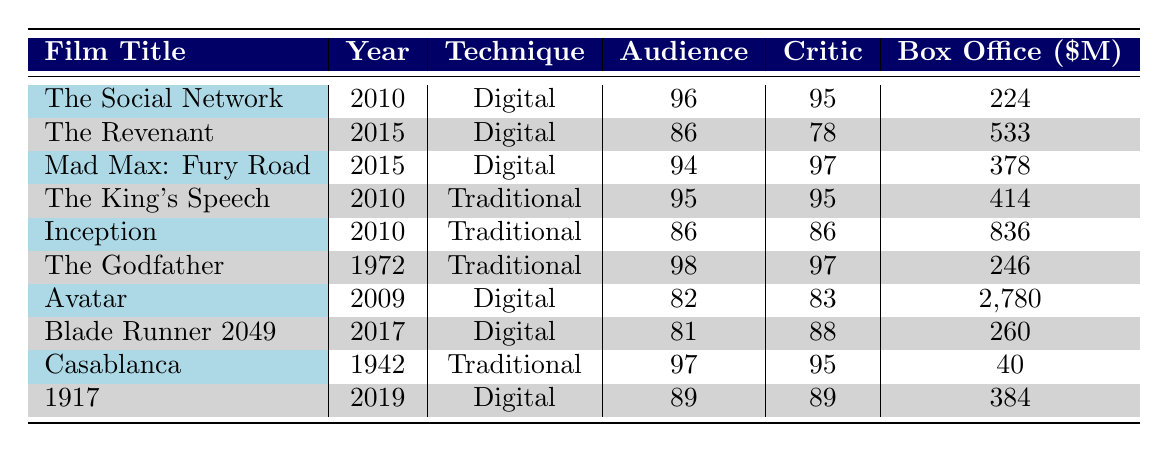What is the highest audience rating for digitally filmed movies? The table shows several digitally filmed movies with their audience ratings. Scanning through the audience ratings of digitally filmed movies: 96 (The Social Network), 86 (The Revenant), 94 (Mad Max: Fury Road), 82 (Avatar), 81 (Blade Runner 2049), and 89 (1917). Here, the highest rating is 96.
Answer: 96 Which film released in 2010 has the highest box office gross? The films released in 2010 are The Social Network and The King's Speech. Their box office grosses are $224 million and $414 million, respectively. Comparing these values, The King's Speech has the highest gross.
Answer: The King's Speech What is the average audience rating of films shot traditionally? The audience ratings for traditionally filmed movies are 95 (The King's Speech), 86 (Inception), 98 (The Godfather), and 97 (Casablanca). To find the average, first sum these ratings: 95 + 86 + 98 + 97 = 376. Then, divide by the number of films, which is 4. The average is 376 / 4 = 94.
Answer: 94 Did any digital film receive a higher critic rating than the audience rating? Looking at the critic ratings compared to the audience ratings for digital films: The Social Network (95 and 96), The Revenant (78 and 86), Mad Max: Fury Road (97 and 94), Avatar (83 and 82), Blade Runner 2049 (88 and 81), and 1917 (89 and 89). The Revenant and Blade Runner 2049 are the only films where the critic rating is lower than the audience rating, so yes, it’s true for those films.
Answer: Yes Which traditional film had the highest box office gross, and how does it compare to the box office of Avatar? The traditional films are The King's Speech, Inception, The Godfather, and Casablanca. Their box office grosses are $414 million, $836 million, $246 million, and $40 million, respectively. Among these, Inception has the highest gross at $836 million. Avatar, which is digitally filmed, grossed $2.78 billion. Comparing $836 million and $2.78 billion shows Avatar's gross is significantly higher.
Answer: Inception; Avatar is higher What is the difference between the audience rating of The Revenant and Mad Max: Fury Road? The audience rating for The Revenant is 86, and for Mad Max: Fury Road, it is 94. To find the difference, subtract the rating of The Revenant from that of Mad Max: Fury Road: 94 - 86 = 8.
Answer: 8 How many films in the table have an audience rating of 90 or above? Analyzing the audience ratings, they are 96 (The Social Network), 86 (The Revenant), 94 (Mad Max: Fury Road), 95 (The King's Speech), 86 (Inception), 98 (The Godfather), 82 (Avatar), 81 (Blade Runner 2049), 97 (Casablanca), and 89 (1917). The ratings above 90 are from The Social Network, Mad Max: Fury Road, The King's Speech, The Godfather, and Casablanca. This totals to five films.
Answer: 5 